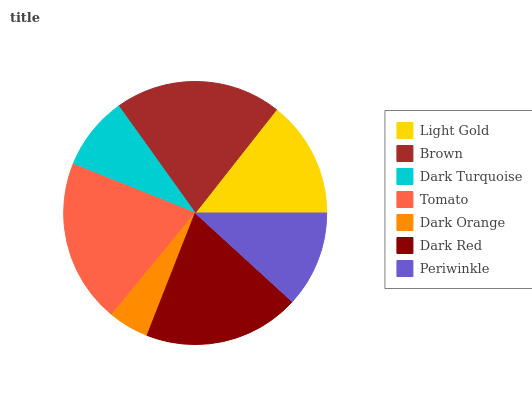Is Dark Orange the minimum?
Answer yes or no. Yes. Is Brown the maximum?
Answer yes or no. Yes. Is Dark Turquoise the minimum?
Answer yes or no. No. Is Dark Turquoise the maximum?
Answer yes or no. No. Is Brown greater than Dark Turquoise?
Answer yes or no. Yes. Is Dark Turquoise less than Brown?
Answer yes or no. Yes. Is Dark Turquoise greater than Brown?
Answer yes or no. No. Is Brown less than Dark Turquoise?
Answer yes or no. No. Is Light Gold the high median?
Answer yes or no. Yes. Is Light Gold the low median?
Answer yes or no. Yes. Is Dark Orange the high median?
Answer yes or no. No. Is Dark Turquoise the low median?
Answer yes or no. No. 